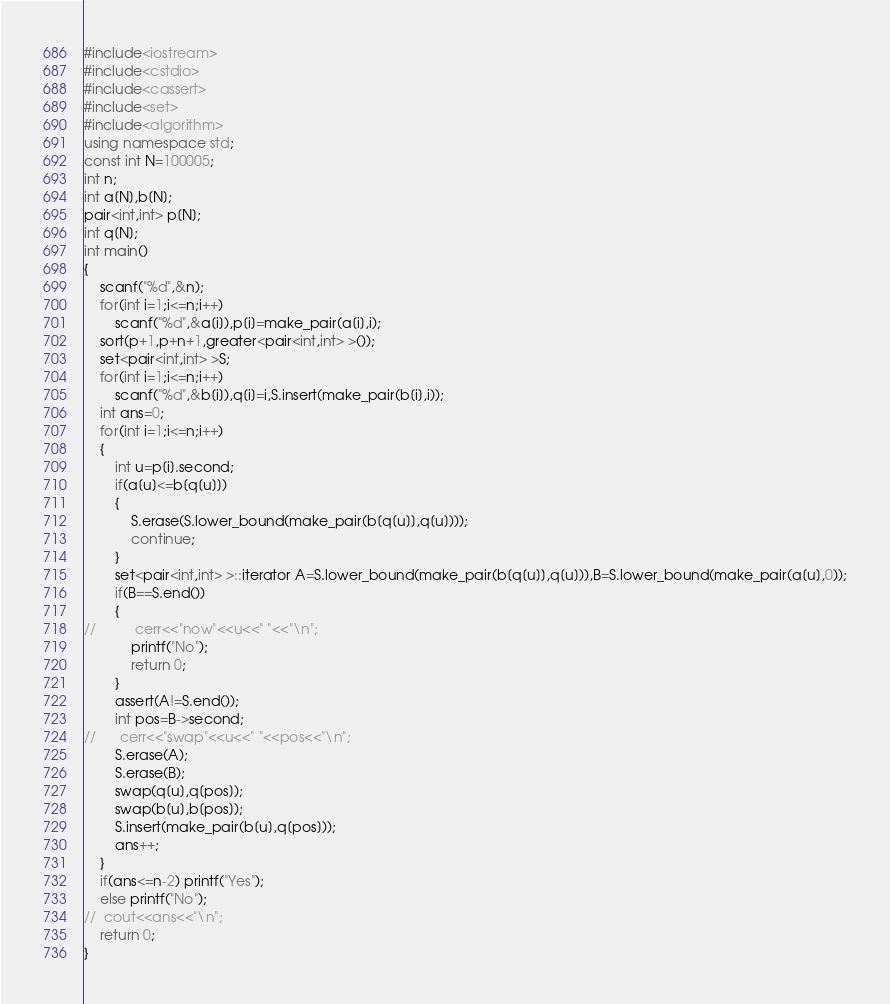Convert code to text. <code><loc_0><loc_0><loc_500><loc_500><_C++_>#include<iostream>
#include<cstdio>
#include<cassert>
#include<set>
#include<algorithm>
using namespace std;
const int N=100005;
int n;
int a[N],b[N];
pair<int,int> p[N];
int q[N];
int main()
{
	scanf("%d",&n);
	for(int i=1;i<=n;i++)
		scanf("%d",&a[i]),p[i]=make_pair(a[i],i);
	sort(p+1,p+n+1,greater<pair<int,int> >());
	set<pair<int,int> >S;
	for(int i=1;i<=n;i++)
		scanf("%d",&b[i]),q[i]=i,S.insert(make_pair(b[i],i));
	int ans=0;
	for(int i=1;i<=n;i++)
	{
		int u=p[i].second;
		if(a[u]<=b[q[u]])
		{
			S.erase(S.lower_bound(make_pair(b[q[u]],q[u])));
			continue;
		}
		set<pair<int,int> >::iterator A=S.lower_bound(make_pair(b[q[u]],q[u])),B=S.lower_bound(make_pair(a[u],0));
		if(B==S.end())
		{
//			cerr<<"now"<<u<<" "<<"\n";
			printf("No");
			return 0;
		}
		assert(A!=S.end());
		int pos=B->second;
//		cerr<<"swap"<<u<<" "<<pos<<"\n";
		S.erase(A);
		S.erase(B);
		swap(q[u],q[pos]);
		swap(b[u],b[pos]);
		S.insert(make_pair(b[u],q[pos]));
		ans++;
	}
	if(ans<=n-2) printf("Yes");
	else printf("No");
//	cout<<ans<<"\n";
	return 0;
}</code> 